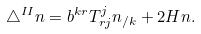Convert formula to latex. <formula><loc_0><loc_0><loc_500><loc_500>\triangle ^ { I I } n = b ^ { k r } T _ { r j } ^ { j } n _ { / k } + 2 H n .</formula> 